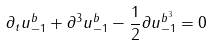Convert formula to latex. <formula><loc_0><loc_0><loc_500><loc_500>\partial _ { t } u _ { - 1 } ^ { b } + \partial ^ { 3 } u _ { - 1 } ^ { b } - \frac { 1 } { 2 } \partial u ^ { b ^ { 3 } } _ { - 1 } = 0</formula> 